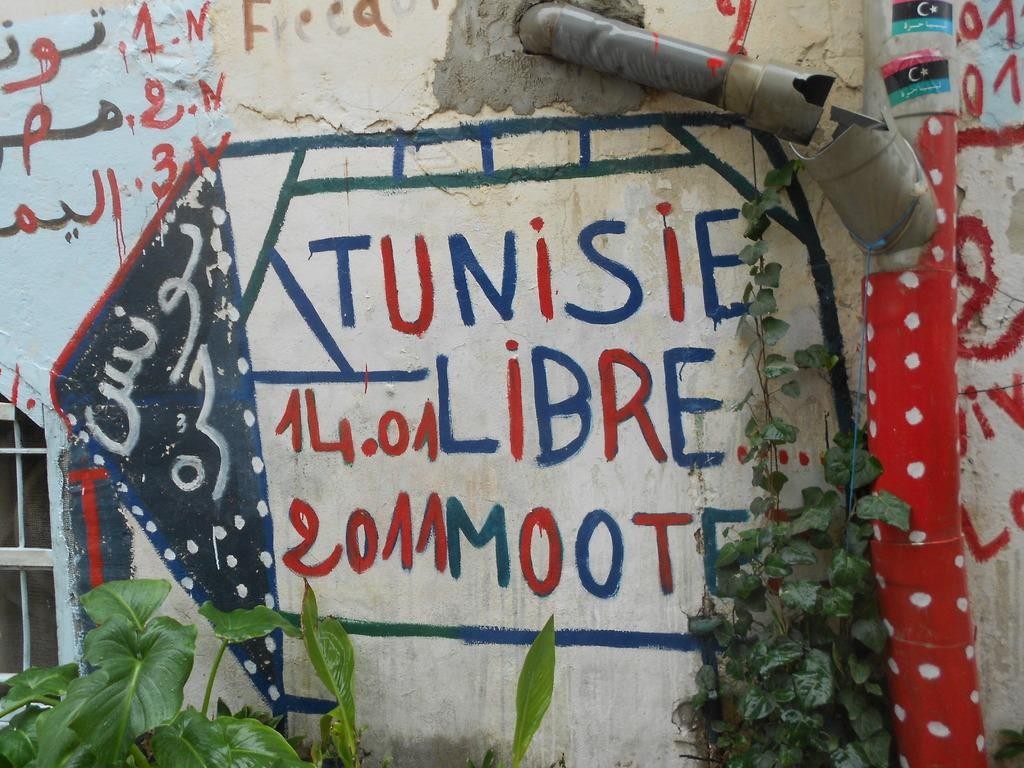What is written or depicted on the wall in the image? There is a wall with text in the image. What other objects can be seen in the image? There is a pipe and a window in the image. What type of vegetation is visible in the image? There are plants visible in the image. How many giants are standing next to the wall in the image? There are no giants present in the image. What color is the sister's knee in the image? There is no sister or knee present in the image. 